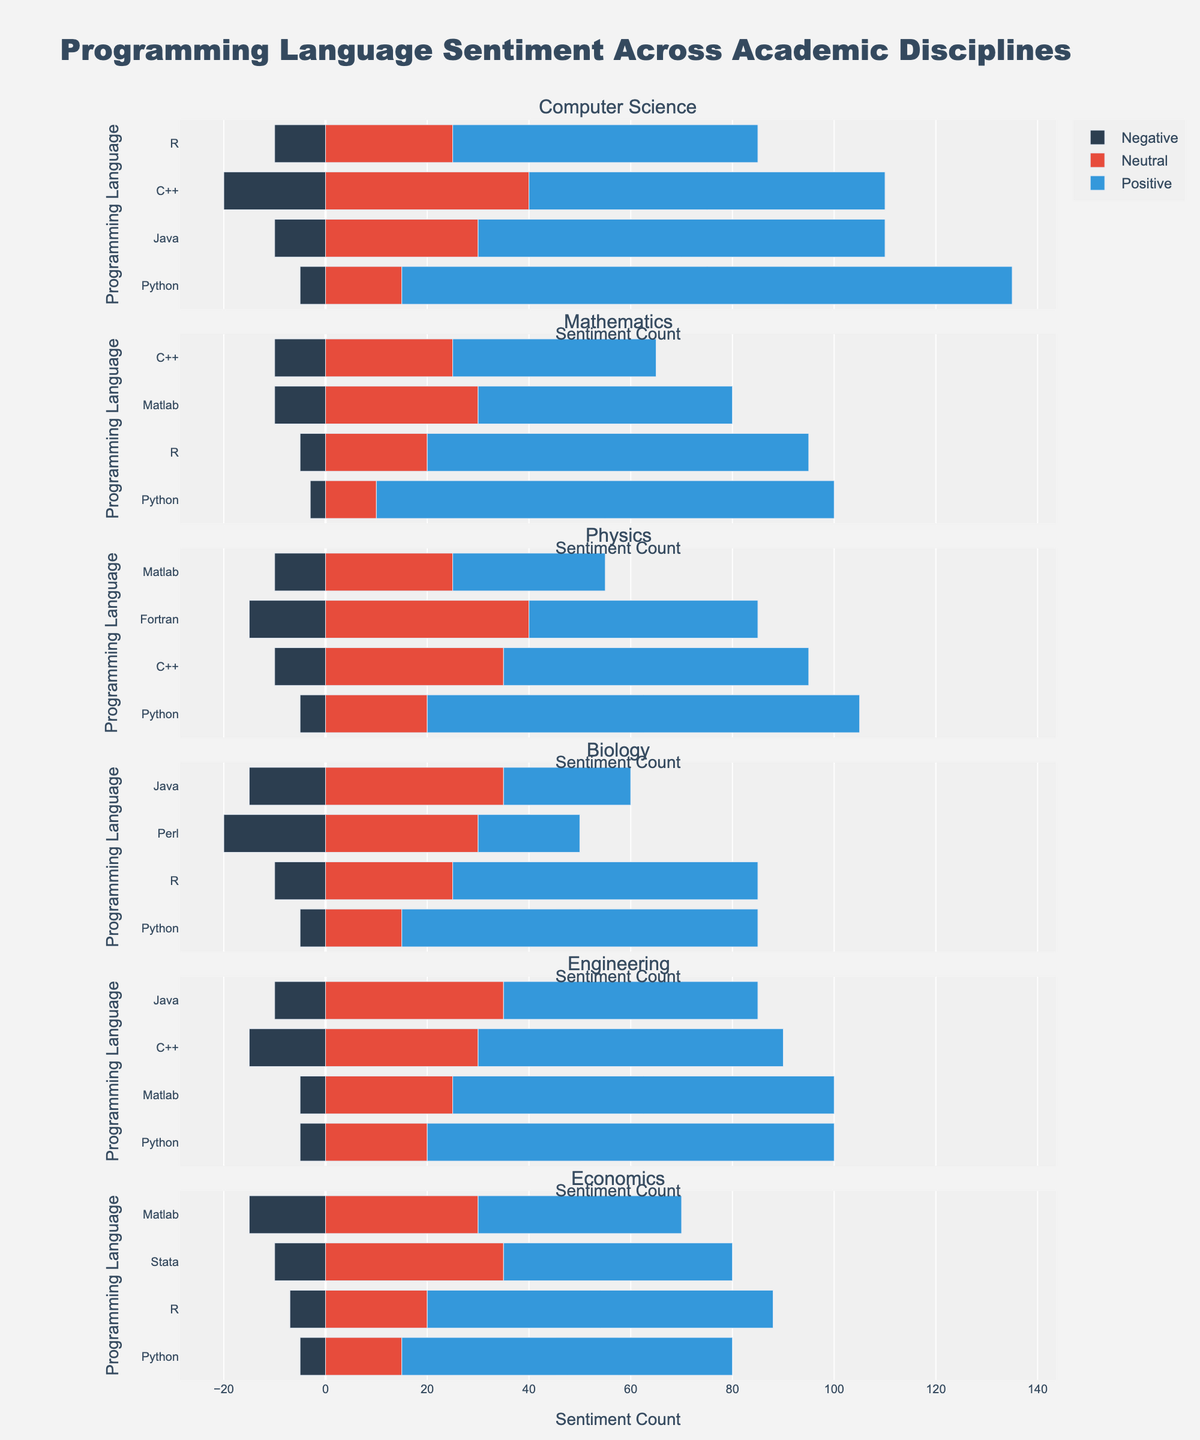What's the favorite programming language in Computer Science based on positive sentiment? Look at the bar lengths for positive sentiment in the "Computer Science" subplot. Python has the longest positive sentiment bar.
Answer: Python Which discipline has the highest negative sentiment for the C++ language? Compare the negative sentiment bars for C++ across all disciplines. Computer Science’s bar is the longest.
Answer: Computer Science What is the net sentiment (positive - negative) for Python in Engineering? For Engineering, the positive sentiment for Python is 80, and the negative sentiment is 5. So, 80 - 5 = 75.
Answer: 75 Compare the positive sentiment for Python between Physics and Biology. Which one is higher? Compare the lengths of the positive sentiment bars for Python in the Physics and Biology subplots. Physics’s bar is slightly longer.
Answer: Physics Among the disciplines listed, which one has the most significant neutral sentiment for Matlab? Compare the neutral sentiment bars for Matlab across all disciplines. Engineering has the longest bar.
Answer: Engineering What is the total sentiment (positive + neutral + negative ignoring the negative sign) for R in Mathematics? Sum the positive, neutral, and negative sentiments for R in Mathematics. So, 75 + 20 + 5 = 100.
Answer: 100 In which discipline is Java received most positively? Compare the positive sentiment bars for Java across all disciplines. Computer Science has the longest bar.
Answer: Computer Science How does the negative sentiment for Fortran in Physics compare to the negative sentiment for Perl in Biology? Compare the lengths of the negative sentiment bars for Fortran in Physics and Perl in Biology. Perl in Biology has a longer bar.
Answer: Perl in Biology Which programming language has the broadest range of sentiments (difference between the highest positive and highest negative sentiment) in Computer Science? For each language in Computer Science, calculate the difference between positive and negative sentiments. Python has the highest range: 120 (positive) - 5 (negative) = 115.
Answer: Python What is the average positive sentiment across all disciplines for the Python programming language? Sum the positive sentiments for Python: 120 (CS) + 90 (Math) + 85 (Physics) + 70 (Biology) + 80 (Eng) + 65 (Econ) = 510. Divide by the number of disciplines, 510 / 6 = 85.
Answer: 85 